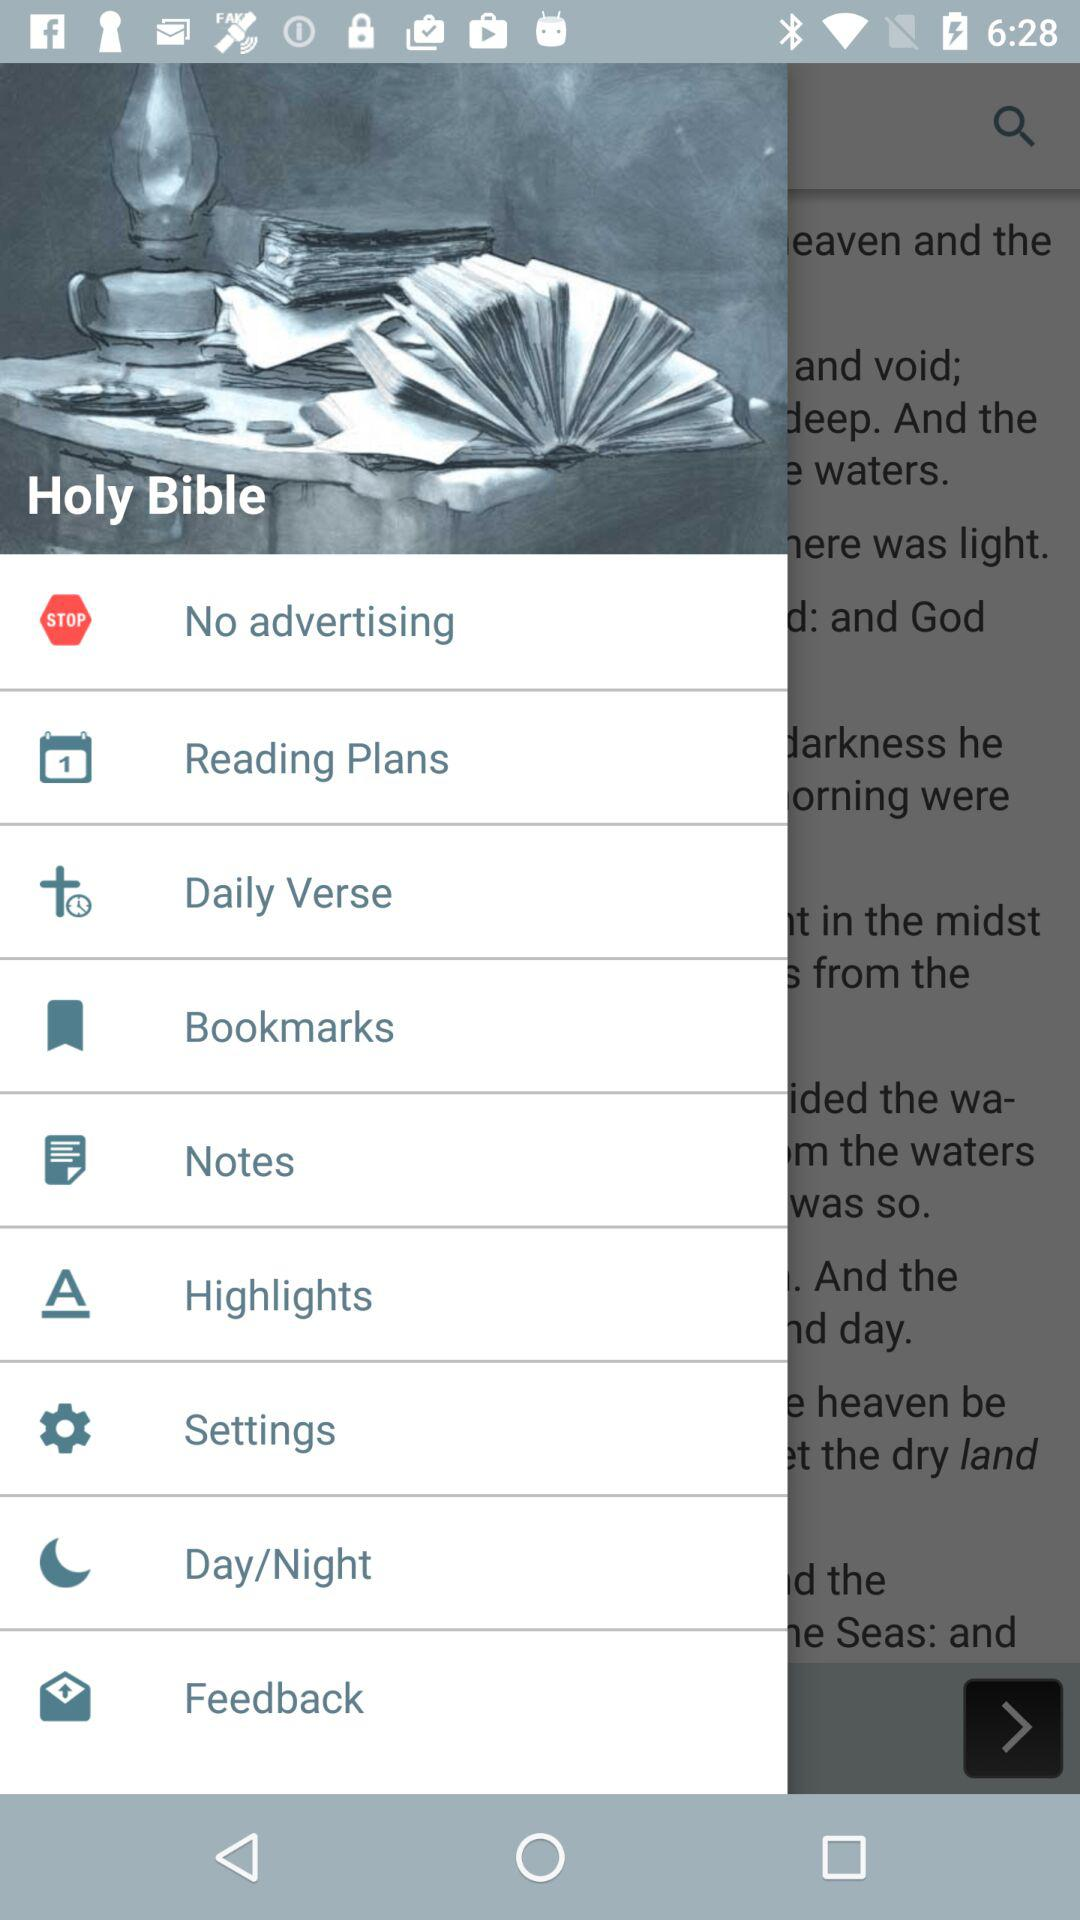What is the name of the application? The name of the application is "Holy Bible". 